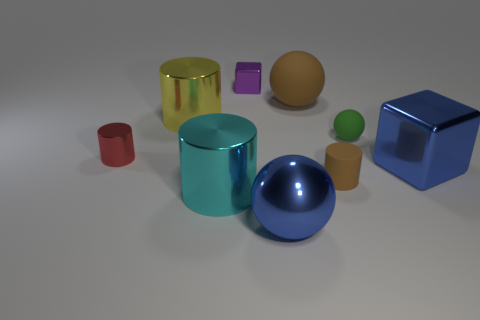Subtract all big blue balls. How many balls are left? 2 Subtract 1 cylinders. How many cylinders are left? 3 Add 1 brown rubber cylinders. How many objects exist? 10 Subtract all yellow cylinders. How many cylinders are left? 3 Subtract all cubes. How many objects are left? 7 Subtract all yellow cylinders. Subtract all yellow blocks. How many cylinders are left? 3 Subtract 0 red blocks. How many objects are left? 9 Subtract all blue matte cylinders. Subtract all large blue spheres. How many objects are left? 8 Add 6 big cylinders. How many big cylinders are left? 8 Add 5 cyan spheres. How many cyan spheres exist? 5 